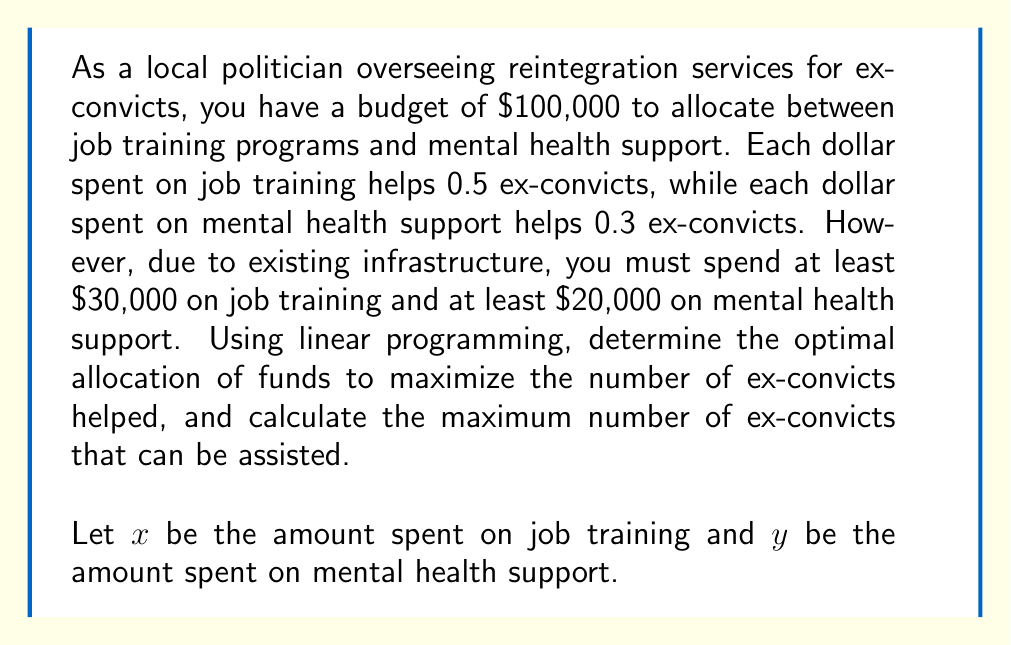Can you solve this math problem? To solve this problem using linear programming, we need to define our objective function and constraints:

Objective function (to maximize):
$$ Z = 0.5x + 0.3y $$

Constraints:
1. Budget constraint: $x + y \leq 100000$
2. Minimum job training: $x \geq 30000$
3. Minimum mental health support: $y \geq 20000$
4. Non-negativity: $x, y \geq 0$

We can solve this using the graphical method:

1. Plot the constraints:
   [asy]
   unitsize(0.00005cm);
   defaultpen(fontsize(10pt));
   
   draw((0,0)--(100000,0), arrow=Arrow(TeXHead));
   draw((0,0)--(0,100000), arrow=Arrow(TeXHead));
   
   draw((0,100000)--(100000,0), blue);
   draw((30000,0)--(30000,100000), red);
   draw((0,20000)--(100000,20000), green);
   
   label("$x$", (100000,0), S);
   label("$y$", (0,100000), W);
   label("$x + y = 100000$", (50000,50000), NW, blue);
   label("$x = 30000$", (30000,50000), E, red);
   label("$y = 20000$", (50000,20000), N, green);
   
   dot((30000,70000));
   dot((80000,20000));
   
   label("A", (30000,70000), NE);
   label("B", (80000,20000), SE);
   [/asy]

2. Identify the feasible region (shaded area).

3. Find the corner points of the feasible region:
   A (30000, 70000) and B (80000, 20000)

4. Evaluate the objective function at these points:
   At A: $Z = 0.5(30000) + 0.3(70000) = 36000$
   At B: $Z = 0.5(80000) + 0.3(20000) = 46000$

5. The maximum value occurs at point B (80000, 20000).

Therefore, the optimal allocation is to spend $80,000 on job training and $20,000 on mental health support. This will help a maximum of 46,000 ex-convicts.
Answer: Optimal allocation: $80,000 on job training, $20,000 on mental health support
Maximum number of ex-convicts helped: 46,000 